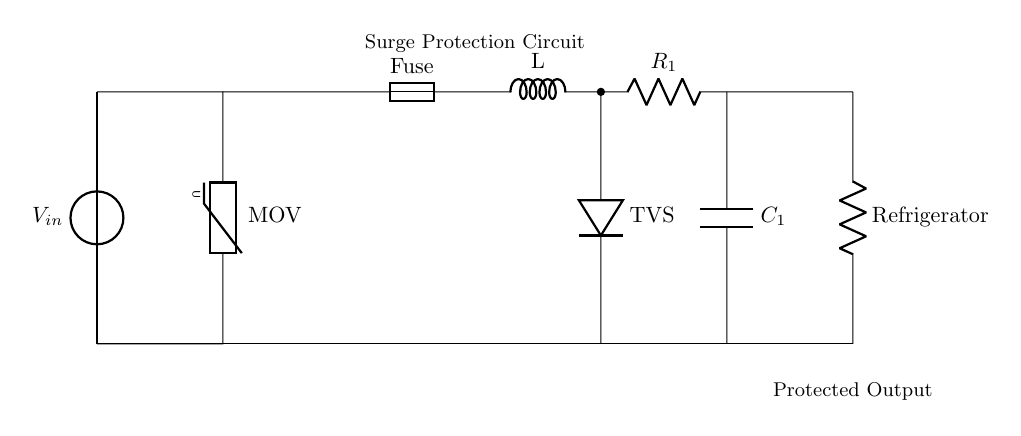What is the main function of the MOV in this circuit? The MOV, or Metal Oxide Varistor, serves to protect the circuit from voltage spikes by clamping excess voltage. This occurs when the voltage exceeds a certain threshold, preventing damage to the refrigerator.
Answer: Voltage spike protection What component is used to protect against overcurrent? The fuse is the component that protects the circuit from overcurrent conditions by breaking the circuit if the current exceeds its rated value.
Answer: Fuse What is the role of the TVS diode in the circuit? The TVS diode acts as a transient voltage suppressor, providing fast clamping to protect sensitive components from voltage spikes that occur in sudden surges.
Answer: Transient voltage suppression Where is the load connected in this circuit? The load, which is the refrigerator, is connected to the output at the rightmost part of the circuit diagram, providing it with the protected power supply.
Answer: Rightmost connection What is the purpose of the capacitor in the circuit? The capacitor, labeled as C1, serves to filter and smoothen the power supply to the refrigerator, helping to stabilize the voltage and reduce ripples.
Answer: Power supply stabilization How does the inductor affect the circuit operation? The inductor, labeled as L, helps to limit the rate of change of current in the circuit, contributing to reducing electromagnetic interference and providing stability under varying load conditions.
Answer: Current stabilization 